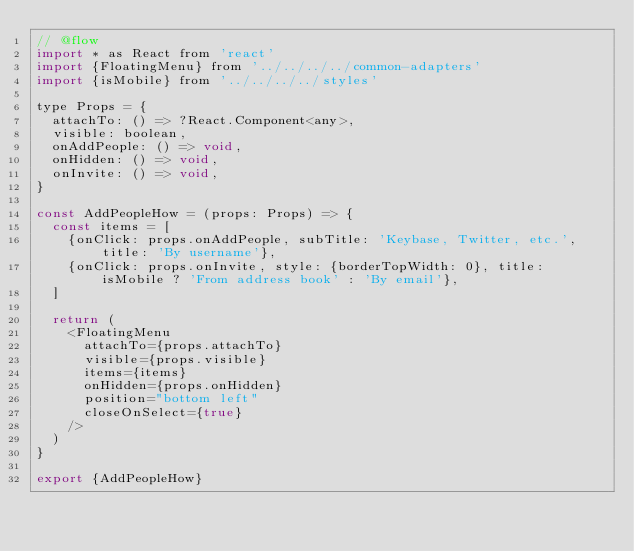<code> <loc_0><loc_0><loc_500><loc_500><_JavaScript_>// @flow
import * as React from 'react'
import {FloatingMenu} from '../../../../common-adapters'
import {isMobile} from '../../../../styles'

type Props = {
  attachTo: () => ?React.Component<any>,
  visible: boolean,
  onAddPeople: () => void,
  onHidden: () => void,
  onInvite: () => void,
}

const AddPeopleHow = (props: Props) => {
  const items = [
    {onClick: props.onAddPeople, subTitle: 'Keybase, Twitter, etc.', title: 'By username'},
    {onClick: props.onInvite, style: {borderTopWidth: 0}, title: isMobile ? 'From address book' : 'By email'},
  ]

  return (
    <FloatingMenu
      attachTo={props.attachTo}
      visible={props.visible}
      items={items}
      onHidden={props.onHidden}
      position="bottom left"
      closeOnSelect={true}
    />
  )
}

export {AddPeopleHow}
</code> 